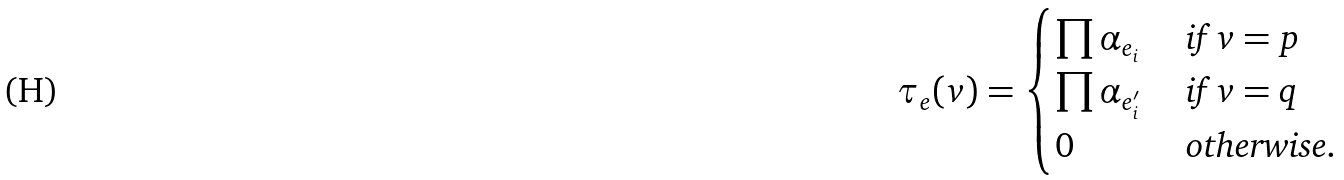Convert formula to latex. <formula><loc_0><loc_0><loc_500><loc_500>\tau _ { e } ( v ) = \begin{cases} \prod \alpha _ { e _ { i } } & \text { if $v=p$} \\ \prod \alpha _ { e _ { i } ^ { \prime } } & \text { if $ v=q$} \\ 0 & \text { otherwise} . \end{cases}</formula> 